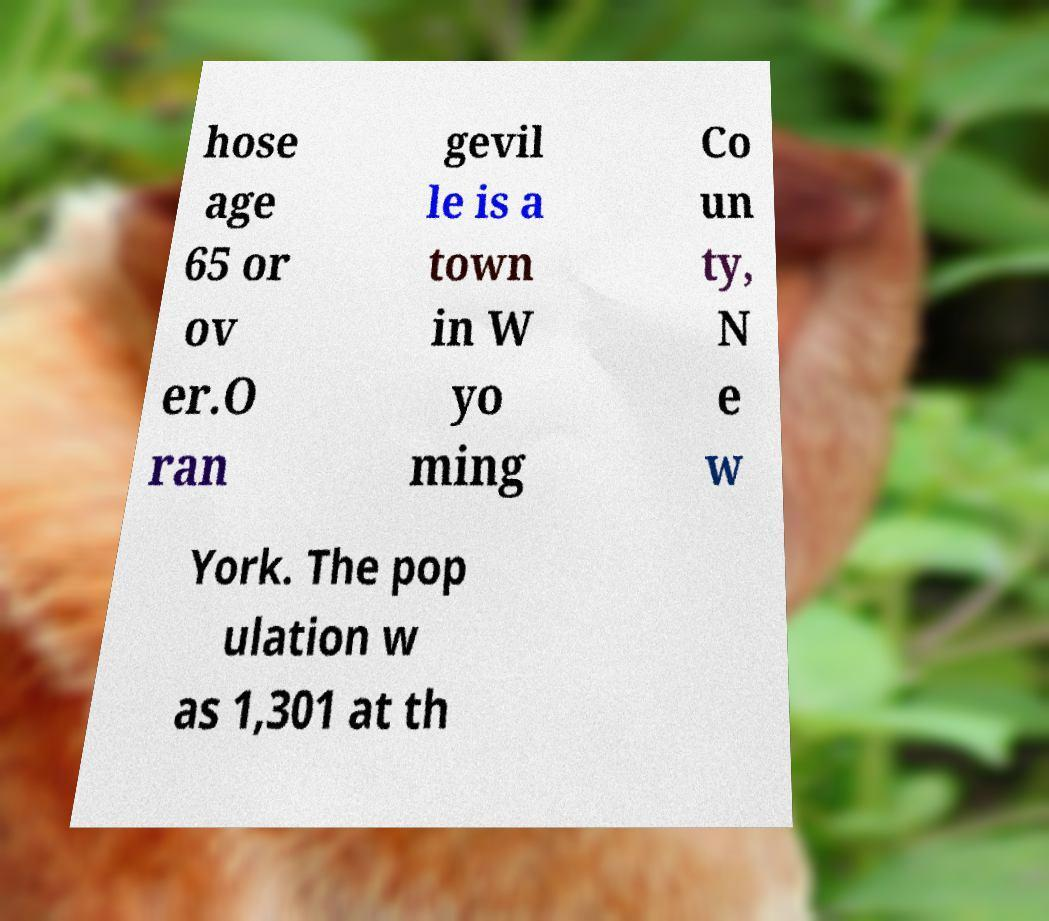Please identify and transcribe the text found in this image. hose age 65 or ov er.O ran gevil le is a town in W yo ming Co un ty, N e w York. The pop ulation w as 1,301 at th 